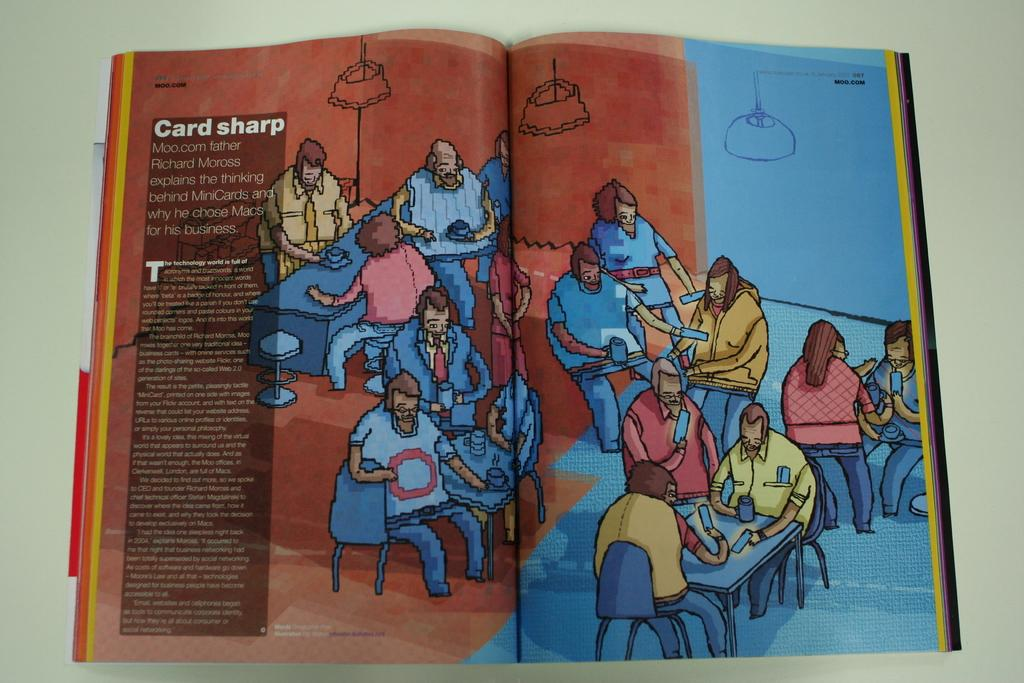<image>
Give a short and clear explanation of the subsequent image. an open book to a picture page with the words 'card sharp' written in white bold letters 